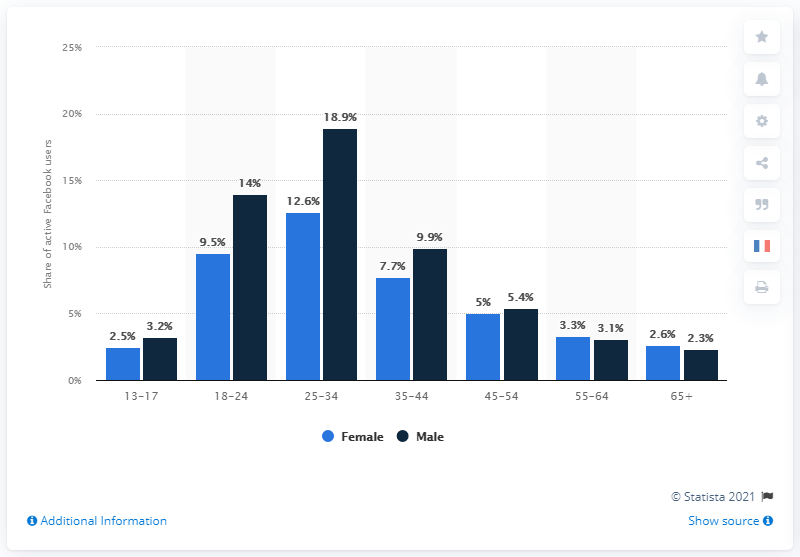Give some essential details in this illustration. The age group with the shortest blue bar is 13-17 year olds. According to data, 9.5% of active Facebook users between the ages of 18 and 24 were women. According to statistics, 9.5% of active Facebook users were women between the ages of 18 and 24. The smallest difference between the male and female share of active Facebook users in the same age group is 0.2%. 